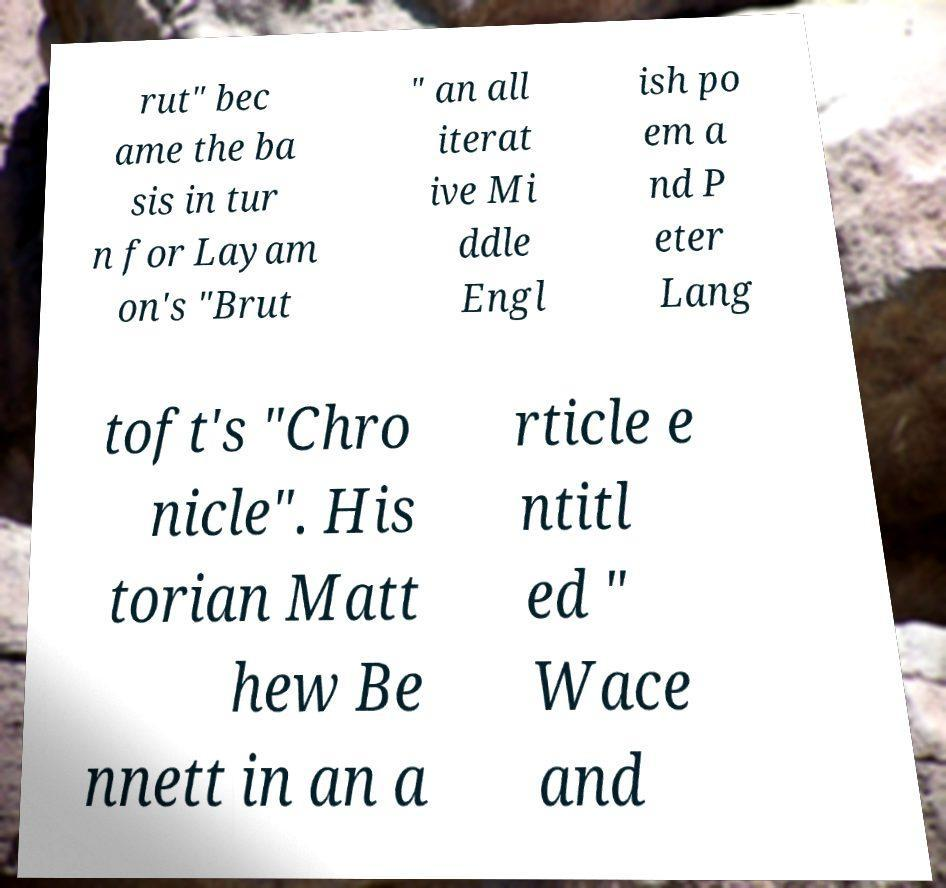Please read and relay the text visible in this image. What does it say? rut" bec ame the ba sis in tur n for Layam on's "Brut " an all iterat ive Mi ddle Engl ish po em a nd P eter Lang toft's "Chro nicle". His torian Matt hew Be nnett in an a rticle e ntitl ed " Wace and 